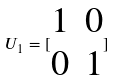<formula> <loc_0><loc_0><loc_500><loc_500>U _ { 1 } = [ \begin{matrix} 1 & 0 \\ 0 & 1 \end{matrix} ]</formula> 